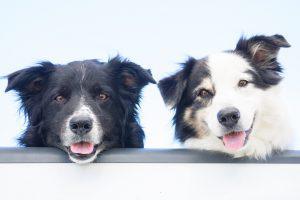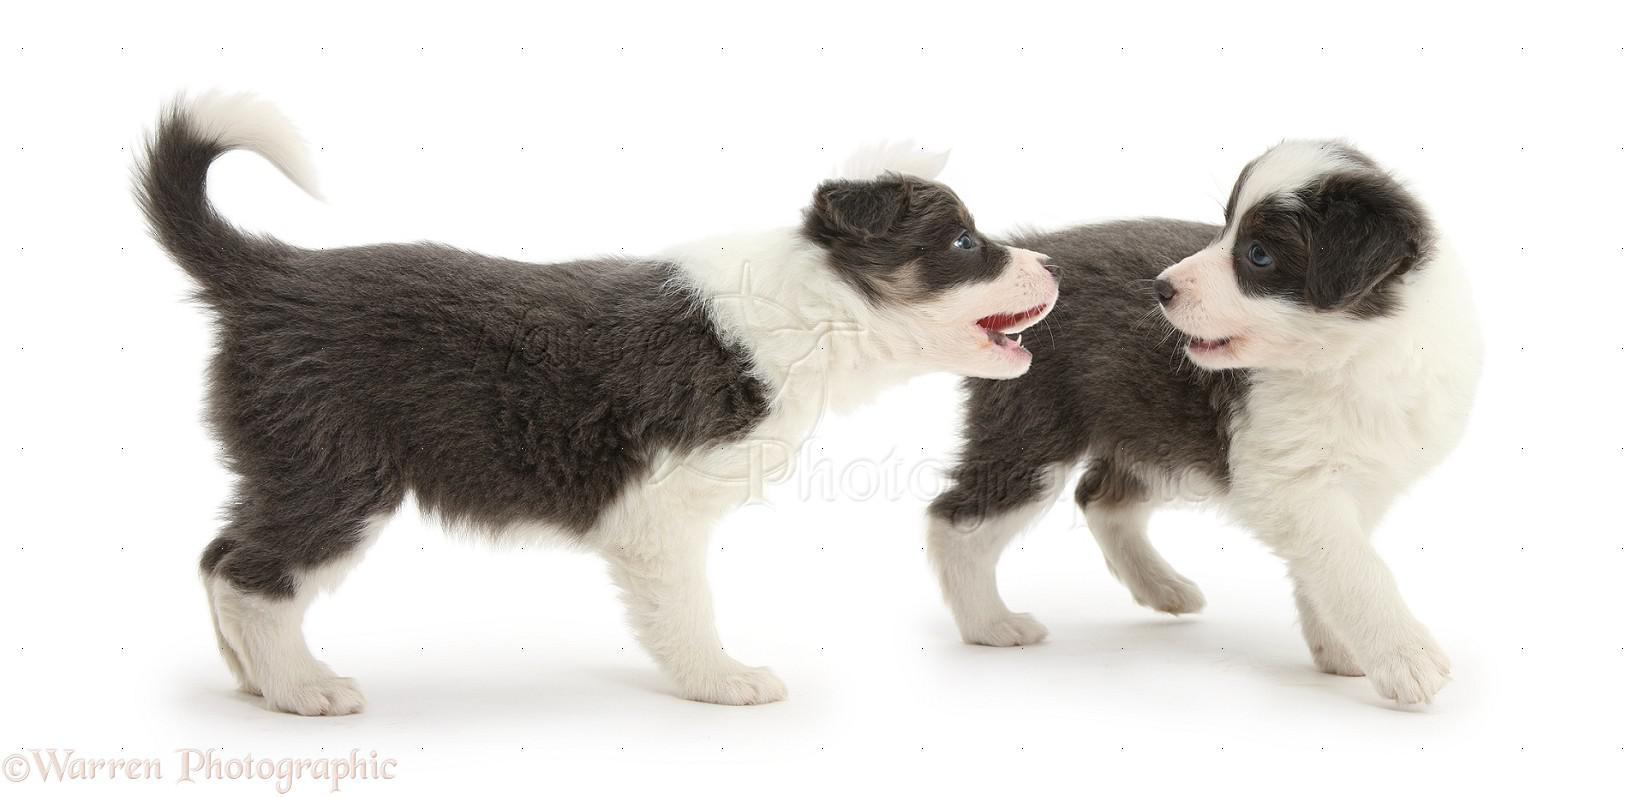The first image is the image on the left, the second image is the image on the right. Examine the images to the left and right. Is the description "There are at most four dogs." accurate? Answer yes or no. Yes. The first image is the image on the left, the second image is the image on the right. Examine the images to the left and right. Is the description "At least one of the dogs is standing up in the image on the right." accurate? Answer yes or no. Yes. 